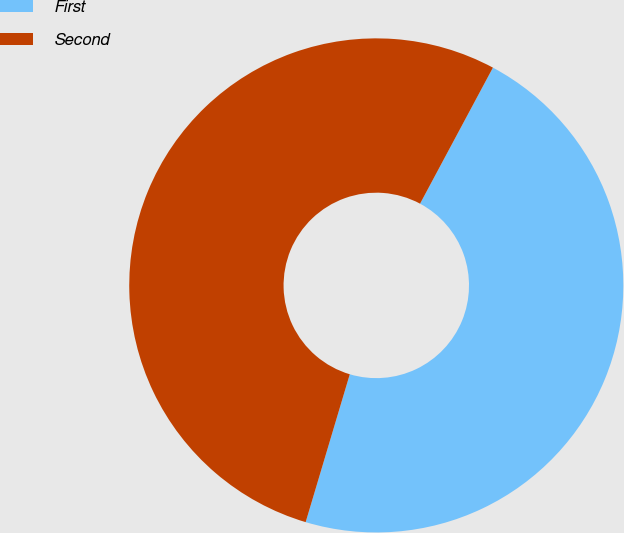Convert chart to OTSL. <chart><loc_0><loc_0><loc_500><loc_500><pie_chart><fcel>First<fcel>Second<nl><fcel>46.79%<fcel>53.21%<nl></chart> 